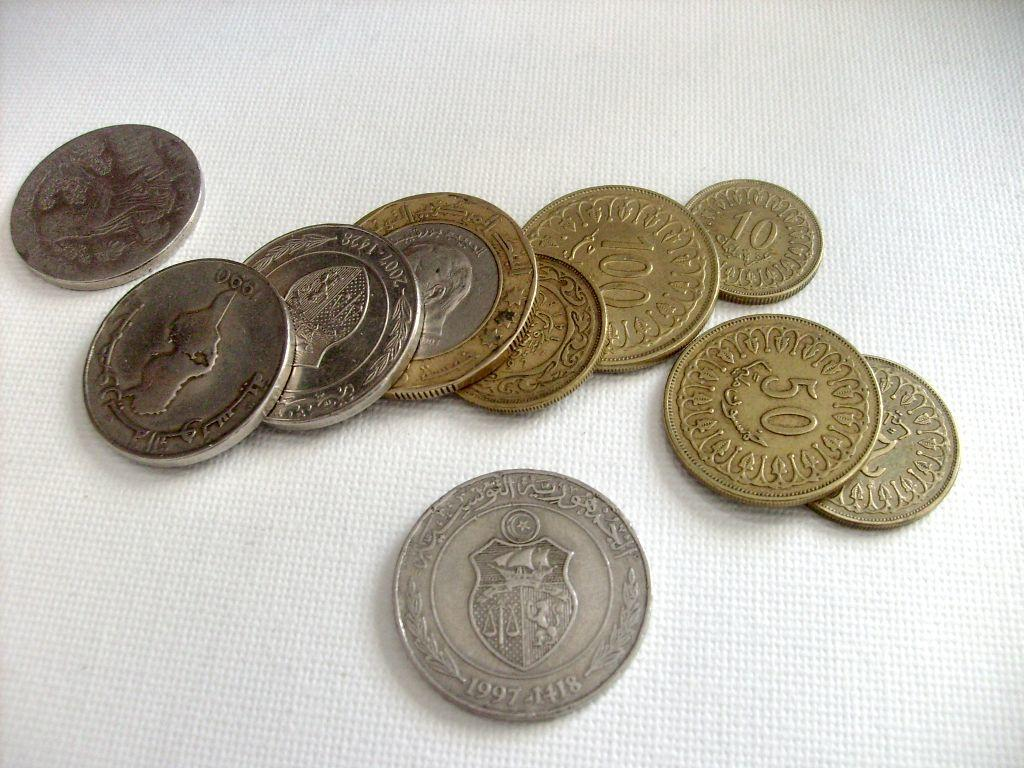<image>
Summarize the visual content of the image. a 50 cent piece on the ground with other 